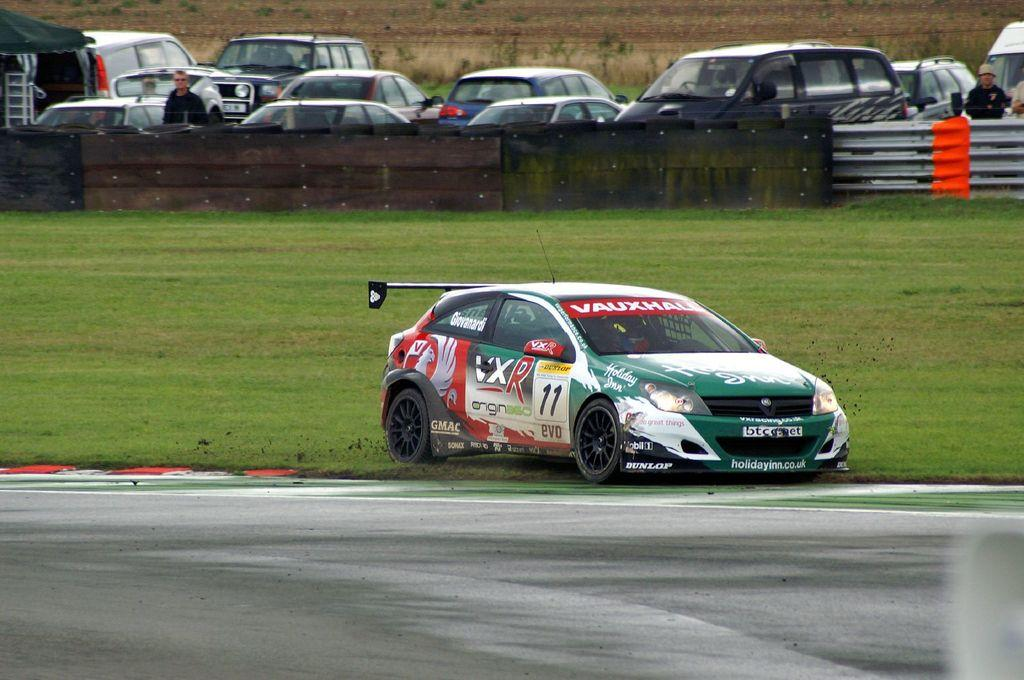What type of vehicles can be seen in the image? There are cars parked in the image. How are some of the cars positioned in the image? Some cars are standing in the image. Can you describe a specific car in the image? There is a racing car in the image. What type of surface is visible on the ground in the image? Grass is present on the ground in the image. What type of barrier is visible in the image? There is a fence in the image. What type of path is visible in the image? There is a road in the image. What type of vest is the grandfather wearing in the image? There is no grandfather or vest present in the image. How does the behavior of the cars change when they see the vest in the image? There is no vest or change in behavior of the cars in the image, as there is no vest or behavior to observe. 